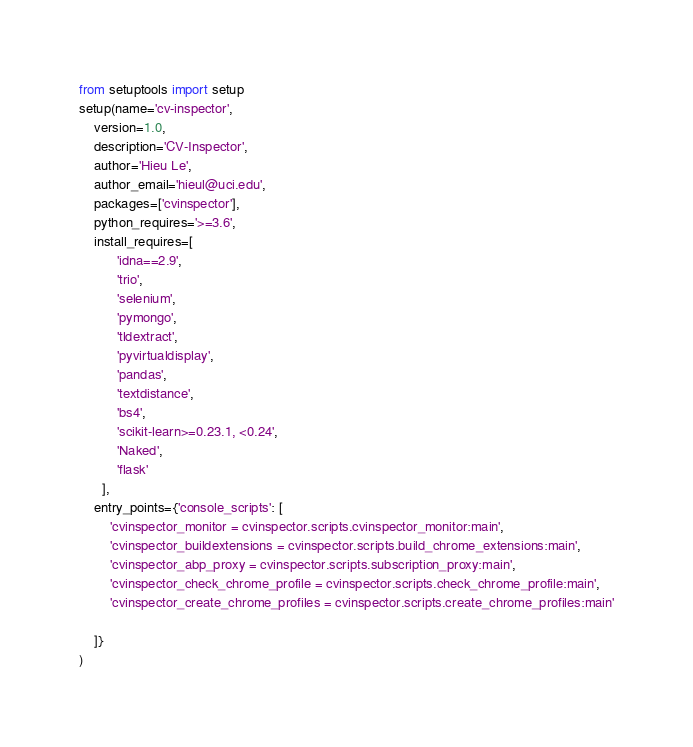<code> <loc_0><loc_0><loc_500><loc_500><_Python_>from setuptools import setup
setup(name='cv-inspector',
    version=1.0,
    description='CV-Inspector',
    author='Hieu Le',
    author_email='hieul@uci.edu',
    packages=['cvinspector'],
    python_requires='>=3.6',
    install_requires=[
          'idna==2.9',
          'trio',
          'selenium',
          'pymongo',
          'tldextract',
          'pyvirtualdisplay',
          'pandas',
          'textdistance',
          'bs4',
          'scikit-learn>=0.23.1, <0.24',
          'Naked',
          'flask'
      ],
    entry_points={'console_scripts': [
        'cvinspector_monitor = cvinspector.scripts.cvinspector_monitor:main',
        'cvinspector_buildextensions = cvinspector.scripts.build_chrome_extensions:main',
        'cvinspector_abp_proxy = cvinspector.scripts.subscription_proxy:main',
        'cvinspector_check_chrome_profile = cvinspector.scripts.check_chrome_profile:main',
        'cvinspector_create_chrome_profiles = cvinspector.scripts.create_chrome_profiles:main'

    ]}
)
</code> 